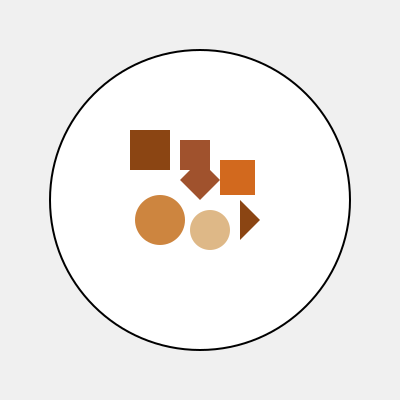In this whimsical mixed-media artwork composition, estimate the number of distinct wooden toy elements used. To estimate the number of distinct wooden toy elements in this artwork, let's break down the composition step-by-step:

1. Identify shapes that represent wooden toys:
   a. Rectangles (3): Likely represent building blocks or toy boxes
   b. Circles (2): Could be wooden beads or wheels
   c. Triangles (1): Might represent a toy pyramid or roof
   d. Polygon (1): Could be a custom-shaped wooden piece

2. Count the distinct elements:
   - 3 rectangles of different sizes
   - 2 circles of different sizes
   - 1 triangle
   - 1 polygon (four-sided irregular shape)

3. Sum up the total number of distinct elements:
   $3 + 2 + 1 + 1 = 7$

Therefore, we can estimate that there are 7 distinct wooden toy elements used in this artwork composition.
Answer: 7 